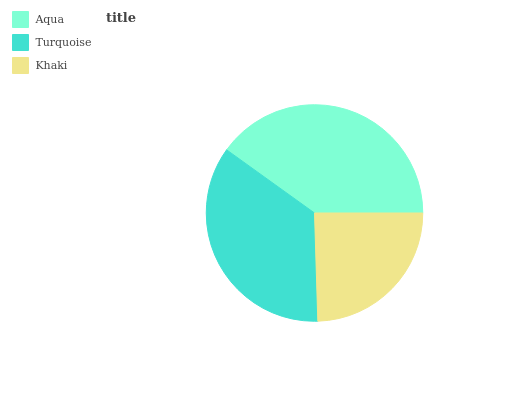Is Khaki the minimum?
Answer yes or no. Yes. Is Aqua the maximum?
Answer yes or no. Yes. Is Turquoise the minimum?
Answer yes or no. No. Is Turquoise the maximum?
Answer yes or no. No. Is Aqua greater than Turquoise?
Answer yes or no. Yes. Is Turquoise less than Aqua?
Answer yes or no. Yes. Is Turquoise greater than Aqua?
Answer yes or no. No. Is Aqua less than Turquoise?
Answer yes or no. No. Is Turquoise the high median?
Answer yes or no. Yes. Is Turquoise the low median?
Answer yes or no. Yes. Is Khaki the high median?
Answer yes or no. No. Is Aqua the low median?
Answer yes or no. No. 